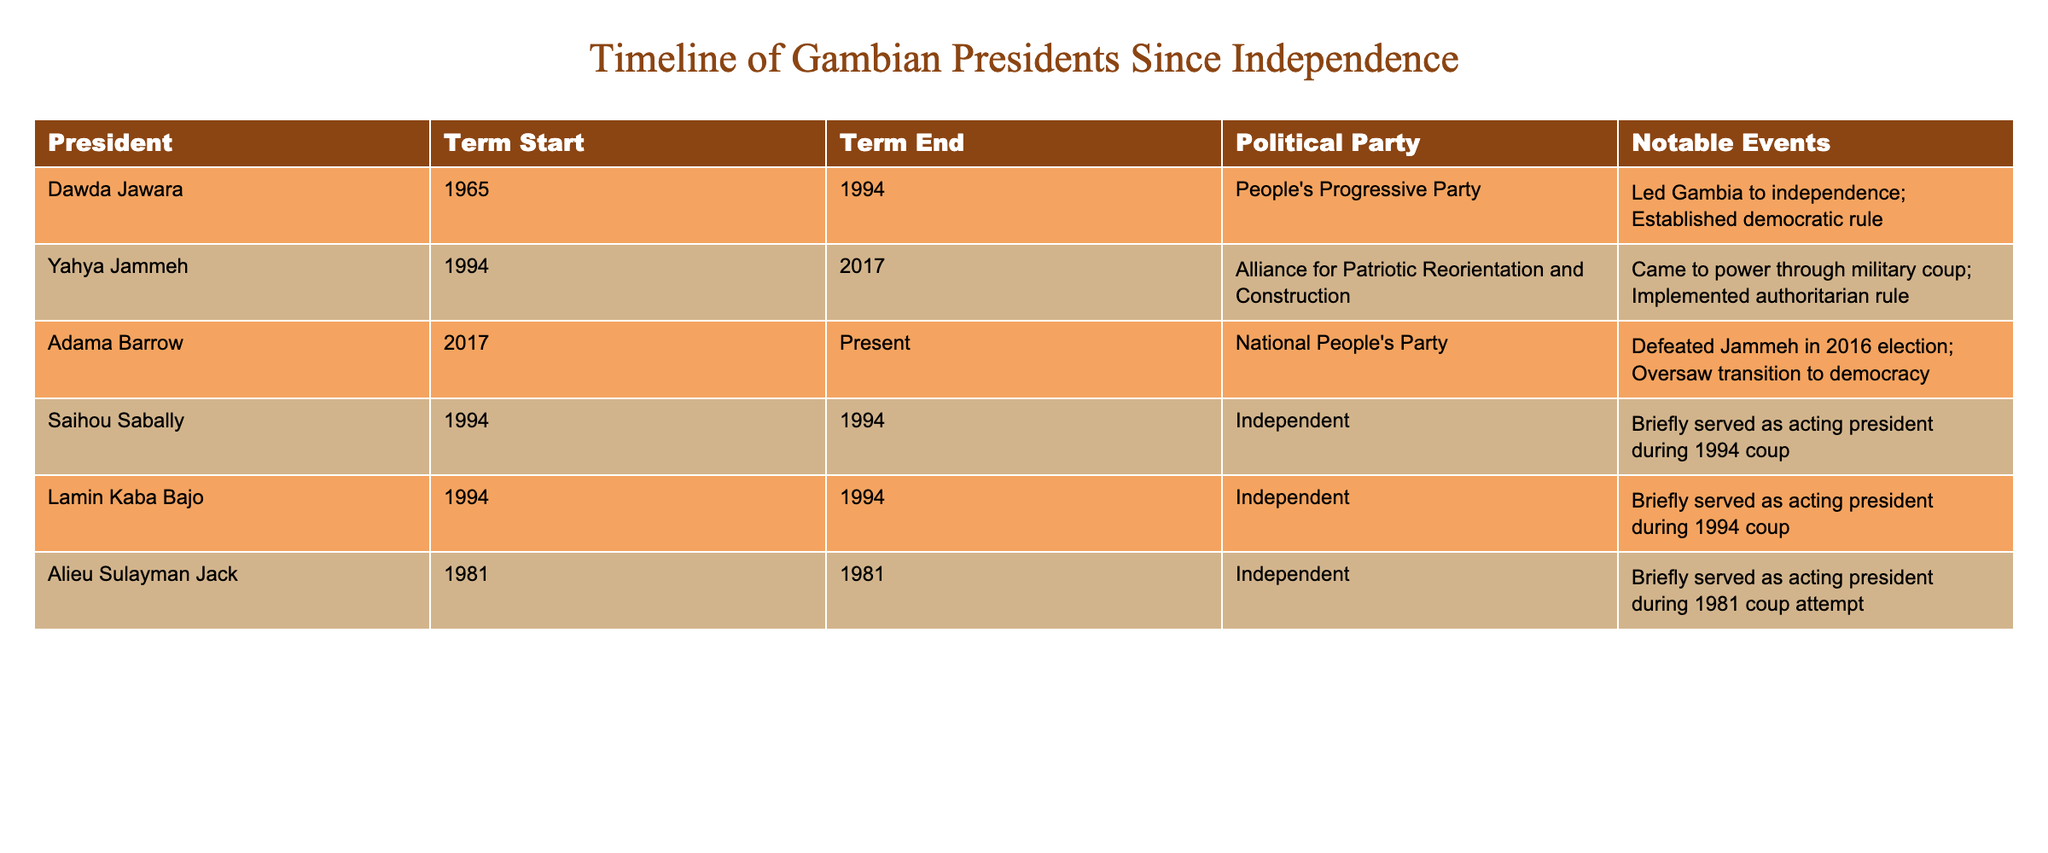What year did Dawda Jawara's term start? According to the table, Dawda Jawara's term started in 1965.
Answer: 1965 Who served as acting president in 1994? The table lists Saihou Sabally and Lamin Kaba Bajo as having briefly served as acting president in 1994.
Answer: Saihou Sabally and Lamin Kaba Bajo What is the political party of Adama Barrow? The table shows that Adama Barrow is from the National People's Party.
Answer: National People's Party How long did Yahya Jammeh serve as president? His term started in 1994 and ended in 2017, therefore he served for 23 years (2017 - 1994).
Answer: 23 years Did Alieu Sulayman Jack belong to a political party during his term? According to the table, he is listed as Independent, which indicates he did not belong to a political party during his term.
Answer: No How many presidents have been in office since 1994? The table shows four presidents who served from 1994 onward: Yahya Jammeh, Saihou Sabally, Lamin Kaba Bajo, and Adama Barrow. Therefore, the count is four.
Answer: 4 Which president led Gambia to independence? The table indicates that Dawda Jawara led Gambia to independence.
Answer: Dawda Jawara What is the term duration of Saihou Sabally? Saihou Sabally's term started and ended in 1994, so he served for less than a year, specifically during the coup in July 1994.
Answer: Less than a year Who was in power prior to Adama Barrow? Yahya Jammeh was the president before Adama Barrow, as shown in the table.
Answer: Yahya Jammeh Which political party has the longest-term president listed? Dawda Jawara with the People's Progressive Party served from 1965 to 1994, totaling 29 years, which is the longest term among the listed presidents.
Answer: People's Progressive Party 